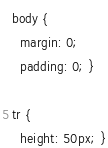<code> <loc_0><loc_0><loc_500><loc_500><_CSS_>body {
  margin: 0;
  padding: 0; }

tr {
  height: 50px; }
</code> 